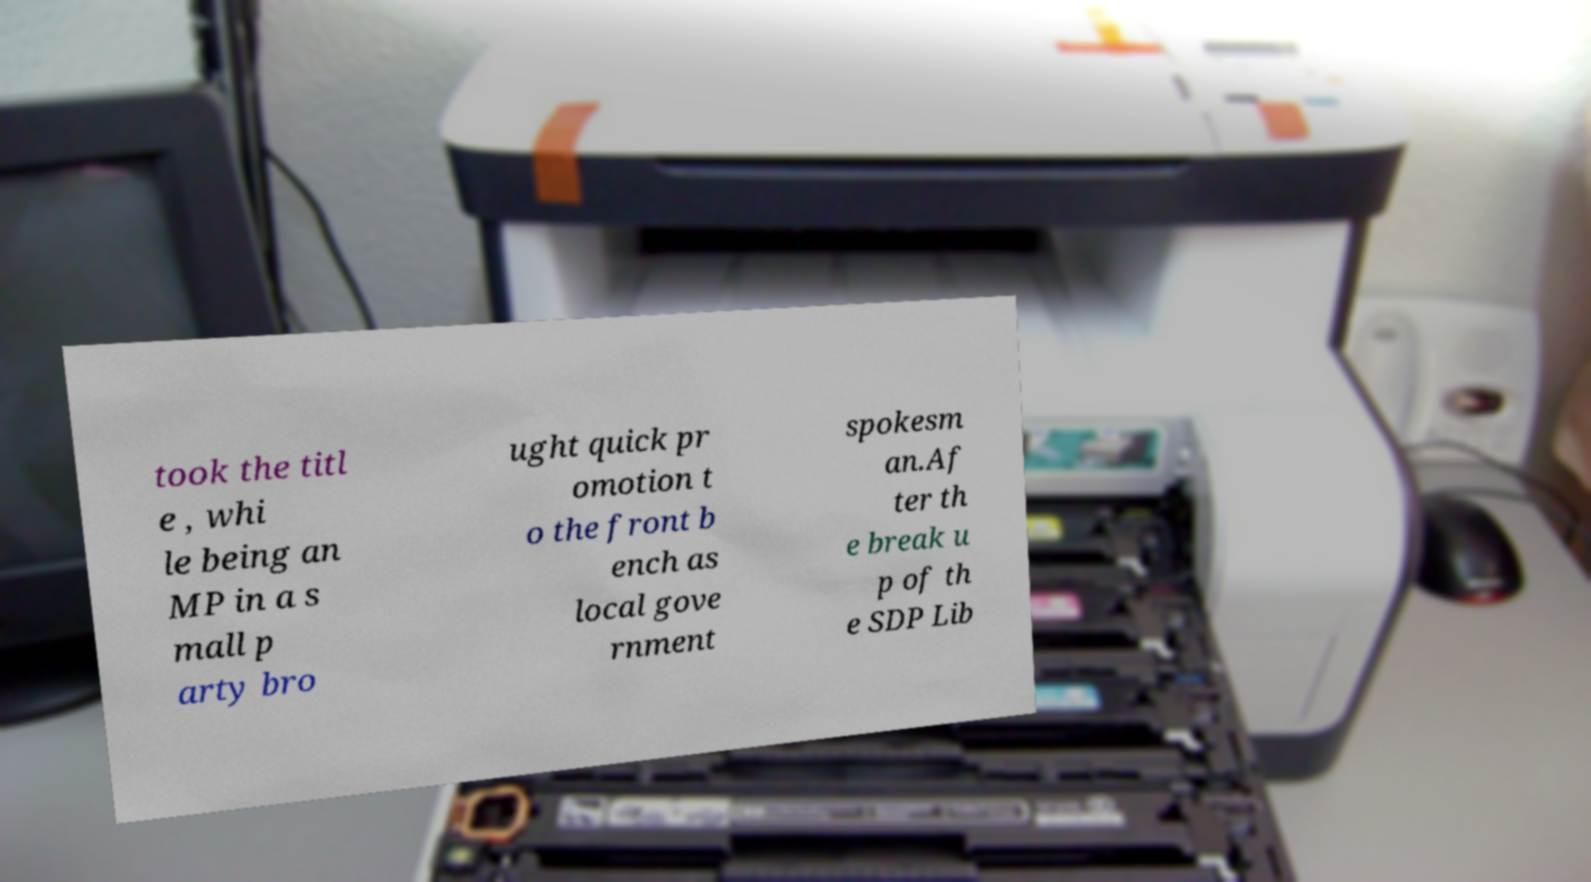For documentation purposes, I need the text within this image transcribed. Could you provide that? took the titl e , whi le being an MP in a s mall p arty bro ught quick pr omotion t o the front b ench as local gove rnment spokesm an.Af ter th e break u p of th e SDP Lib 